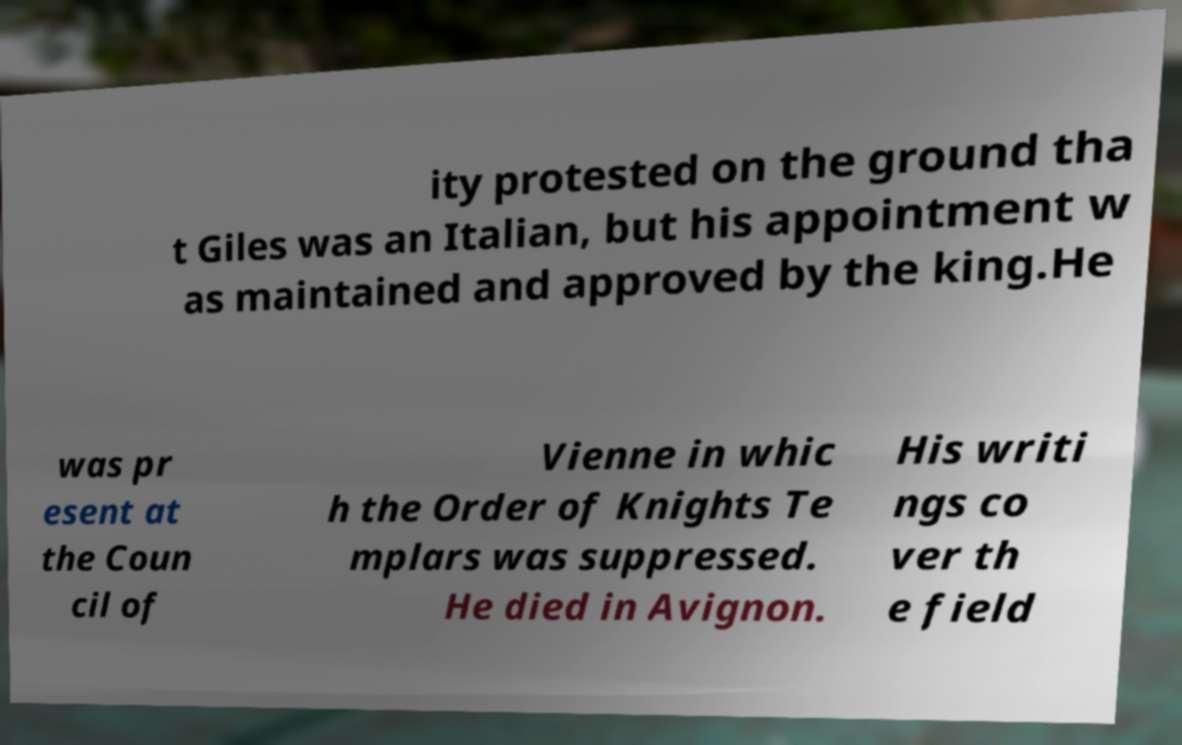I need the written content from this picture converted into text. Can you do that? ity protested on the ground tha t Giles was an Italian, but his appointment w as maintained and approved by the king.He was pr esent at the Coun cil of Vienne in whic h the Order of Knights Te mplars was suppressed. He died in Avignon. His writi ngs co ver th e field 